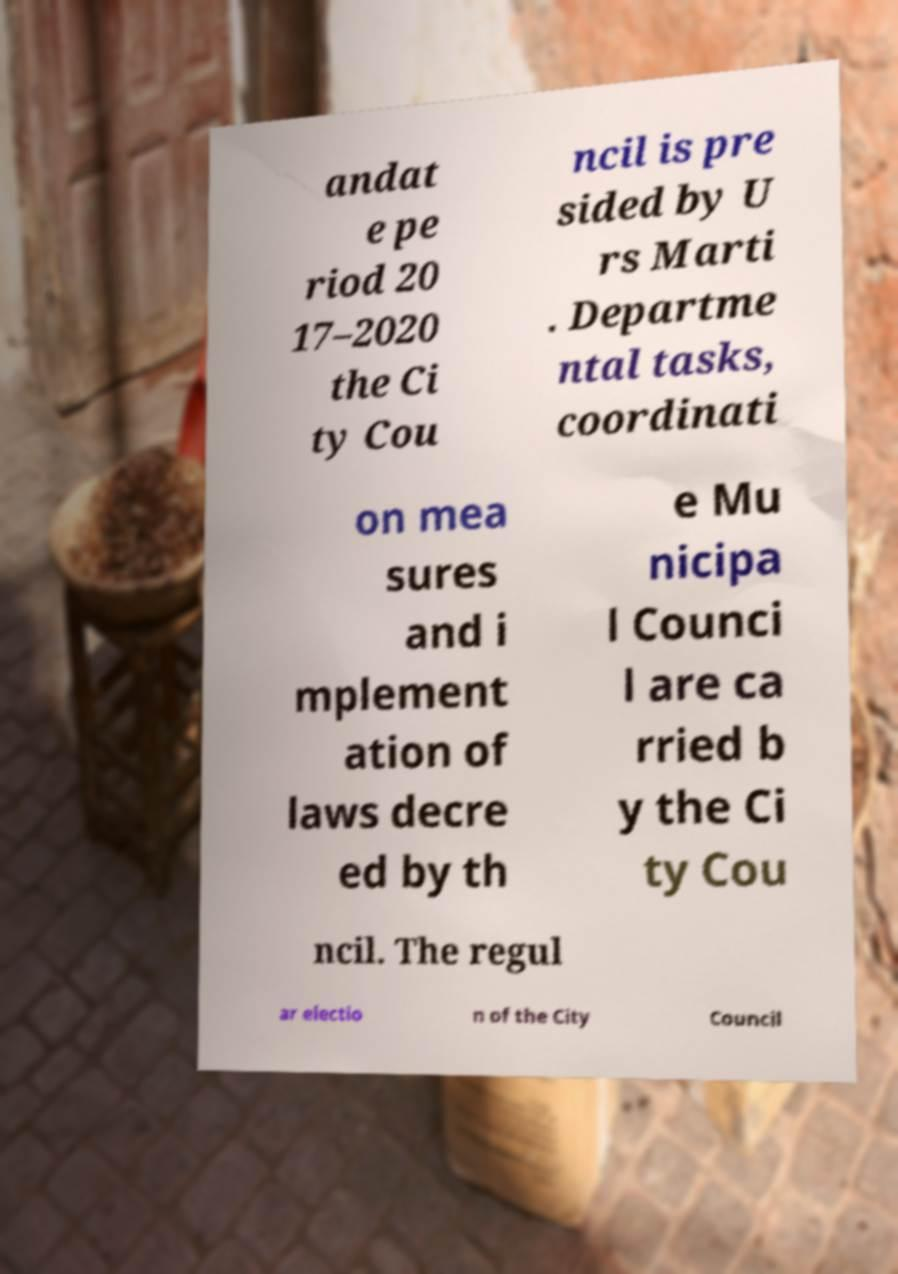Could you assist in decoding the text presented in this image and type it out clearly? andat e pe riod 20 17–2020 the Ci ty Cou ncil is pre sided by U rs Marti . Departme ntal tasks, coordinati on mea sures and i mplement ation of laws decre ed by th e Mu nicipa l Counci l are ca rried b y the Ci ty Cou ncil. The regul ar electio n of the City Council 